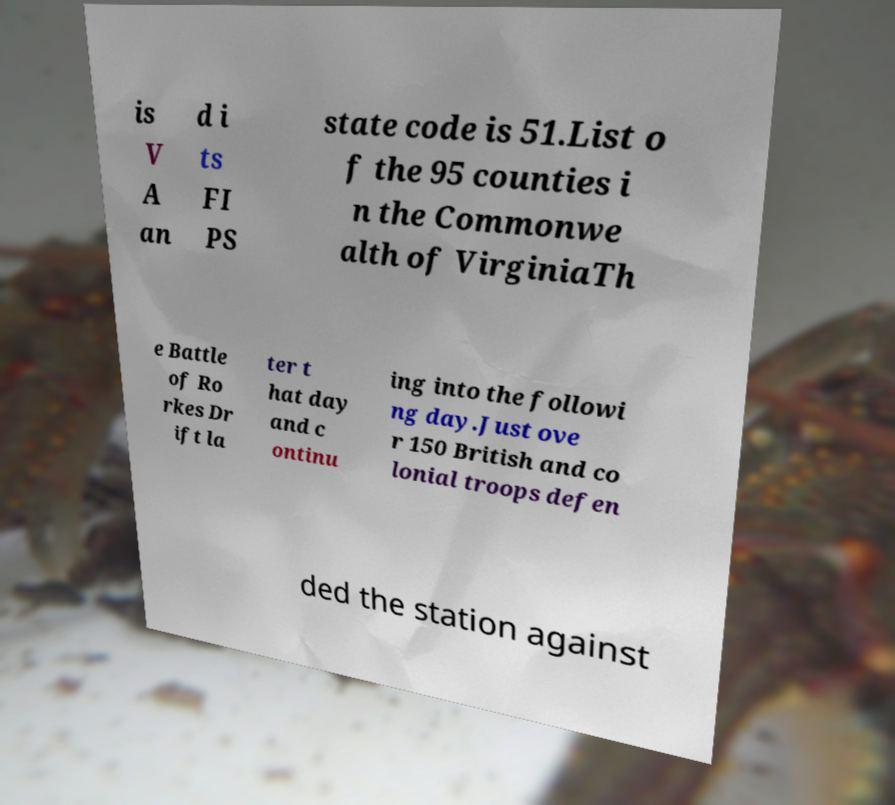For documentation purposes, I need the text within this image transcribed. Could you provide that? is V A an d i ts FI PS state code is 51.List o f the 95 counties i n the Commonwe alth of VirginiaTh e Battle of Ro rkes Dr ift la ter t hat day and c ontinu ing into the followi ng day.Just ove r 150 British and co lonial troops defen ded the station against 